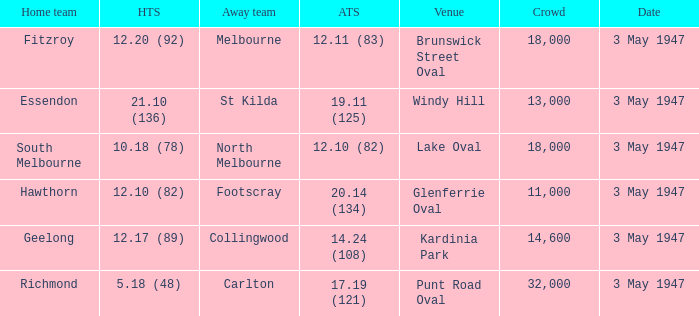In the game where the home team scored 12.17 (89), who was the home team? Geelong. 